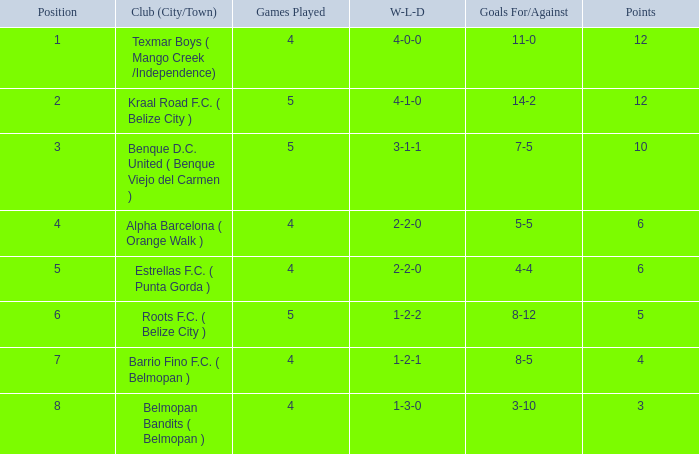What is the minimum number of games played with a 7-5 goal ratio? 5.0. 